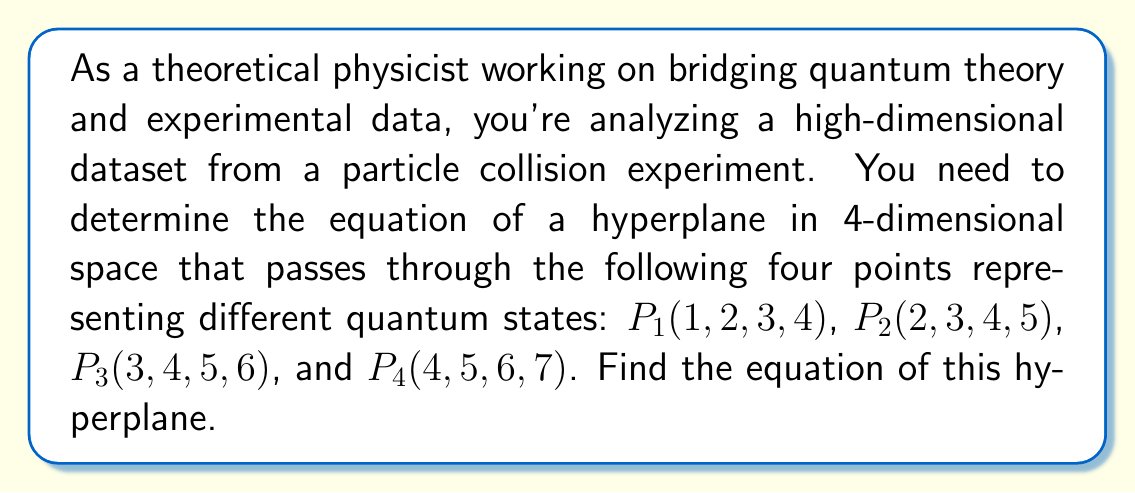Solve this math problem. To determine the equation of a hyperplane in n-dimensional space given n points, we can follow these steps:

1) The general equation of a hyperplane in 4D space is:
   $$Ax + By + Cz + Dw + E = 0$$

2) We need to find the values of A, B, C, D, and E that satisfy this equation for all given points.

3) Let's start by finding a normal vector to the hyperplane. We can do this by calculating three vectors between our points and then taking their cross product:

   $\vec{v_1} = P_2 - P_1 = (1, 1, 1, 1)$
   $\vec{v_2} = P_3 - P_1 = (2, 2, 2, 2)$
   $\vec{v_3} = P_4 - P_1 = (3, 3, 3, 3)$

4) The normal vector $\vec{n}$ is the cross product of these vectors. In 4D, this is a bit complex, but we can use the fact that $\vec{n}$ should be perpendicular to all $\vec{v_i}$. One such vector is $\vec{n} = (1, -1, 1, -1)$.

5) The coefficients A, B, C, and D in our hyperplane equation are the components of this normal vector:

   $$1x - 1y + 1z - 1w + E = 0$$

6) To find E, we can substitute the coordinates of any of our points. Let's use $P_1(1, 2, 3, 4)$:

   $$1(1) - 1(2) + 1(3) - 1(4) + E = 0$$
   $$1 - 2 + 3 - 4 + E = 0$$
   $$E = 2$$

7) Therefore, the equation of our hyperplane is:

   $$x - y + z - w + 2 = 0$$

This hyperplane equation represents the quantum states that are in the same "slice" of our 4D space as our original four points, potentially revealing important relationships in our particle collision data.
Answer: $x - y + z - w + 2 = 0$ 